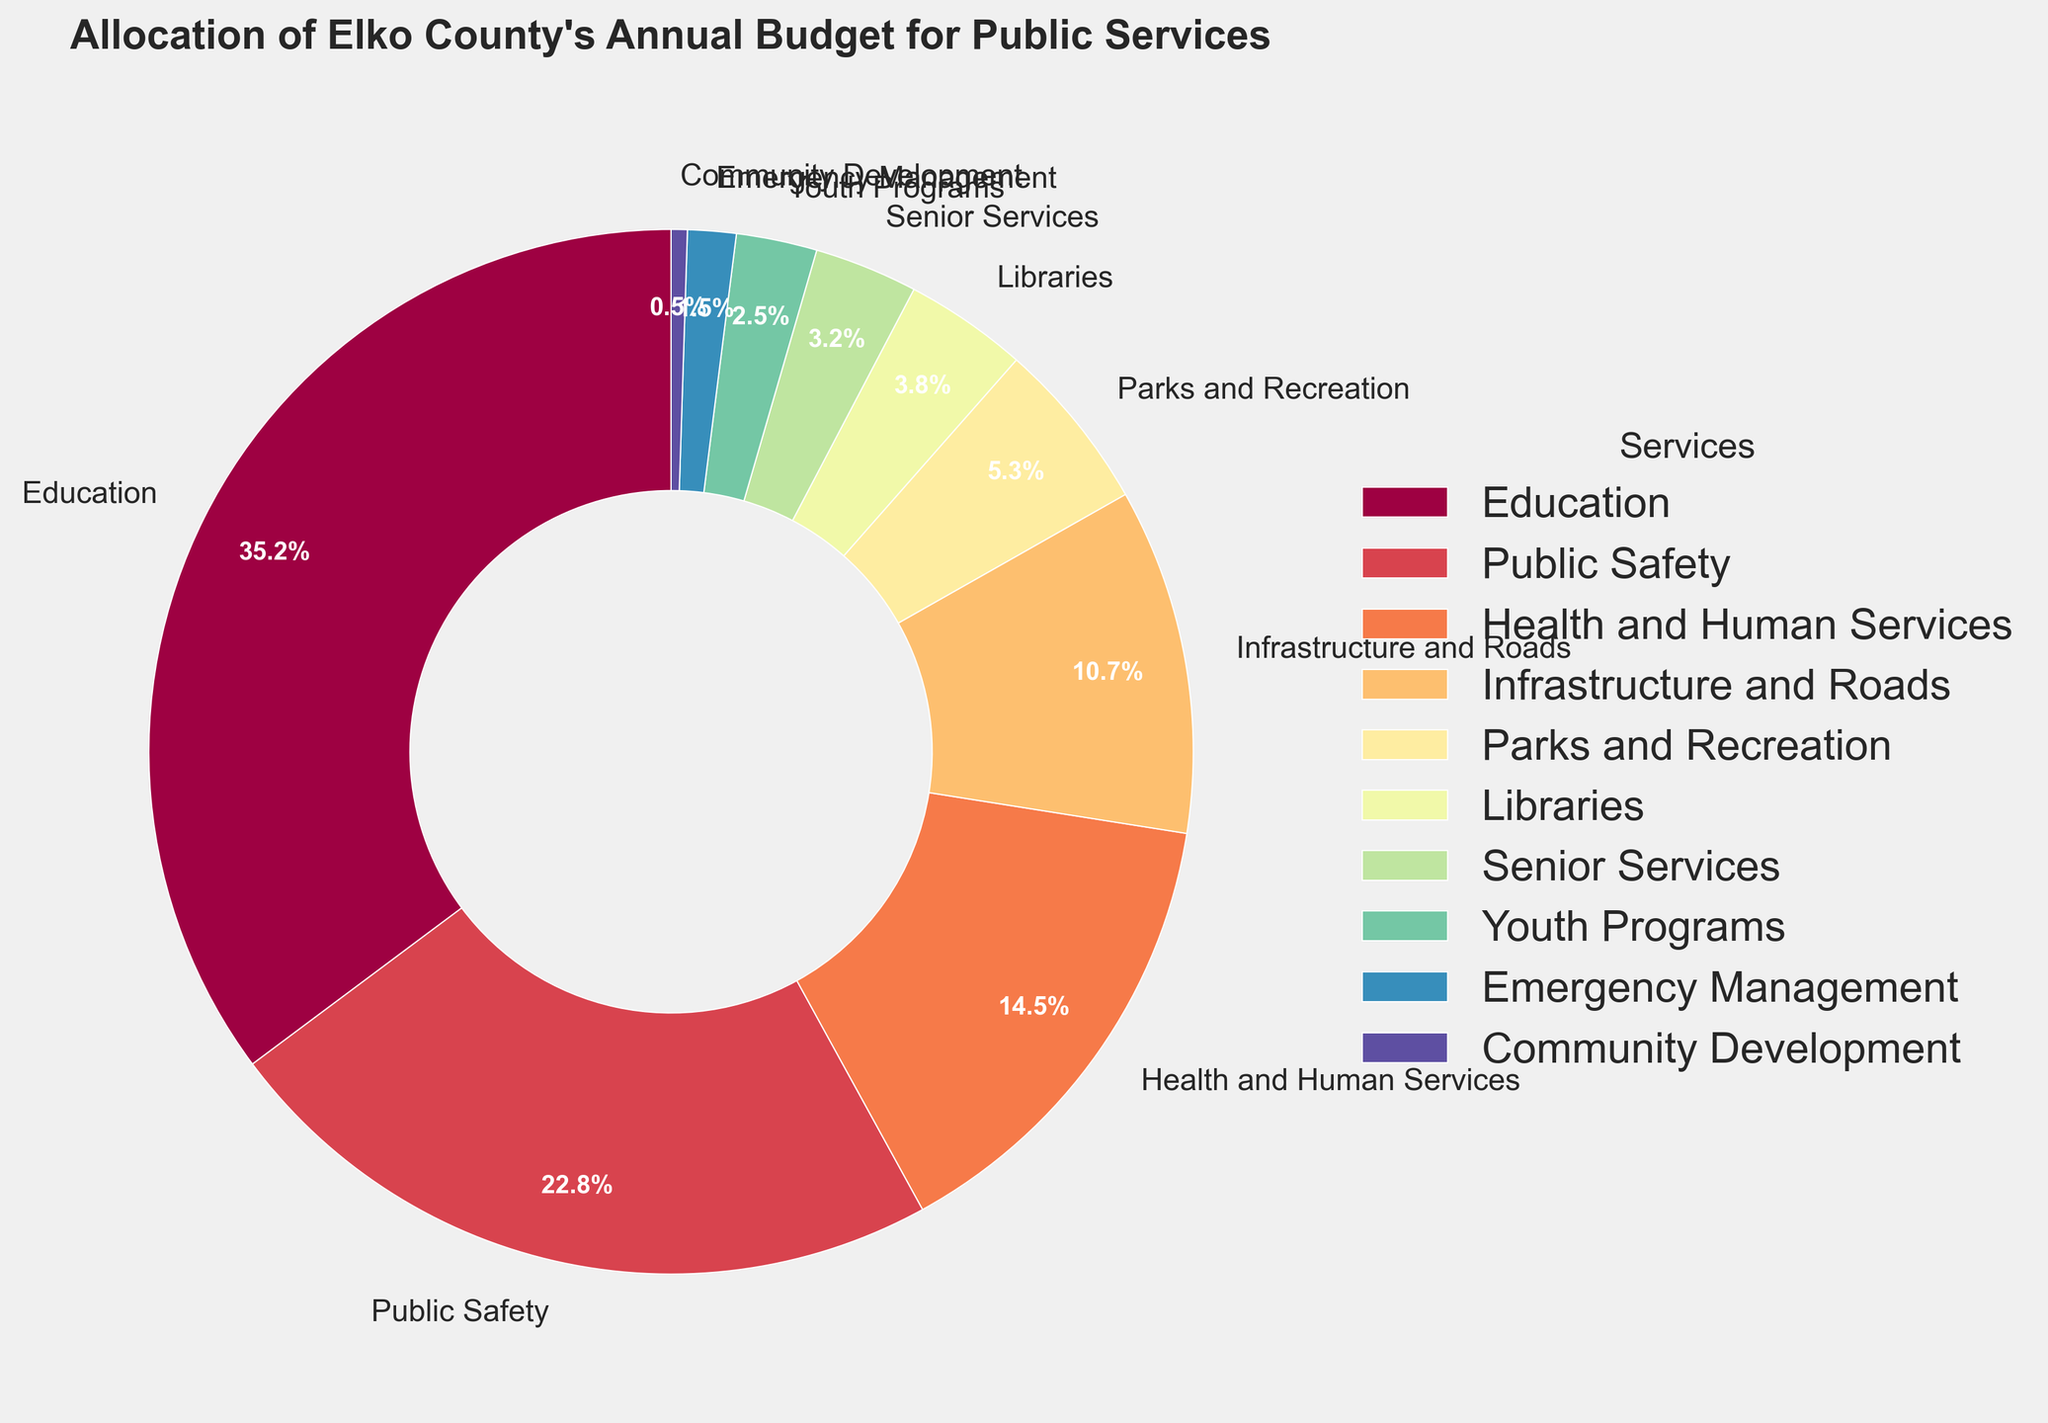Which service receives the highest percentage of the budget? By looking at the pie chart, the slice labeled "Education" is the largest, which means it receives the highest percentage of the budget.
Answer: Education What is the combined budget percentage for Health and Human Services and Senior Services? The percentage for Health and Human Services is 14.5% and for Senior Services is 3.2%. Adding these together, 14.5% + 3.2% = 17.7%.
Answer: 17.7% How much more is allocated to Public Safety compared to Youth Programs? Public Safety receives 22.8% of the budget while Youth Programs receive 2.5%. The difference is 22.8% - 2.5% = 20.3%.
Answer: 20.3% Which services have an allocated budget percentage below 5%? Observing the pie chart, the services with less than 5% allocation are Parks and Recreation, Libraries, Senior Services, Youth Programs, Emergency Management, and Community Development.
Answer: Parks and Recreation, Libraries, Senior Services, Youth Programs, Emergency Management, Community Development Is the budget for Infrastructure and Roads more than half of the budget for Education? The budget for Education is 35.2%. Half of this amount is 35.2% / 2 = 17.6%. The budget for Infrastructure and Roads is 10.7%, which is less than 17.6%.
Answer: No What is the difference in budget percentage between Parks and Recreation and Libraries? Parks and Recreation have a budget of 5.3% and Libraries have 3.8%. The difference is 5.3% - 3.8% = 1.5%.
Answer: 1.5% Which service has the smallest wedge in the pie chart? The smallest wedge in the pie chart is labeled "Community Development," indicating it has the smallest budget percentage.
Answer: Community Development Are there more services with a budget above or below 10%? Services above 10% include Education, Public Safety, Health and Human Services, and Infrastructure and Roads (4 services). Services below 10% include Parks and Recreation, Libraries, Senior Services, Youth Programs, Emergency Management, and Community Development (6 services).
Answer: Below What is the total budget percentage allocated to services that receive over 20%? The only services that receive over 20% are Education (35.2%) and Public Safety (22.8%). Adding these gives 35.2% + 22.8% = 58%.
Answer: 58% How does the budget for Emergency Management compare visually to the budget for Education? The slice for Emergency Management is significantly smaller than the slice for Education, indicating that Education has a much larger budget allocation.
Answer: Much smaller 